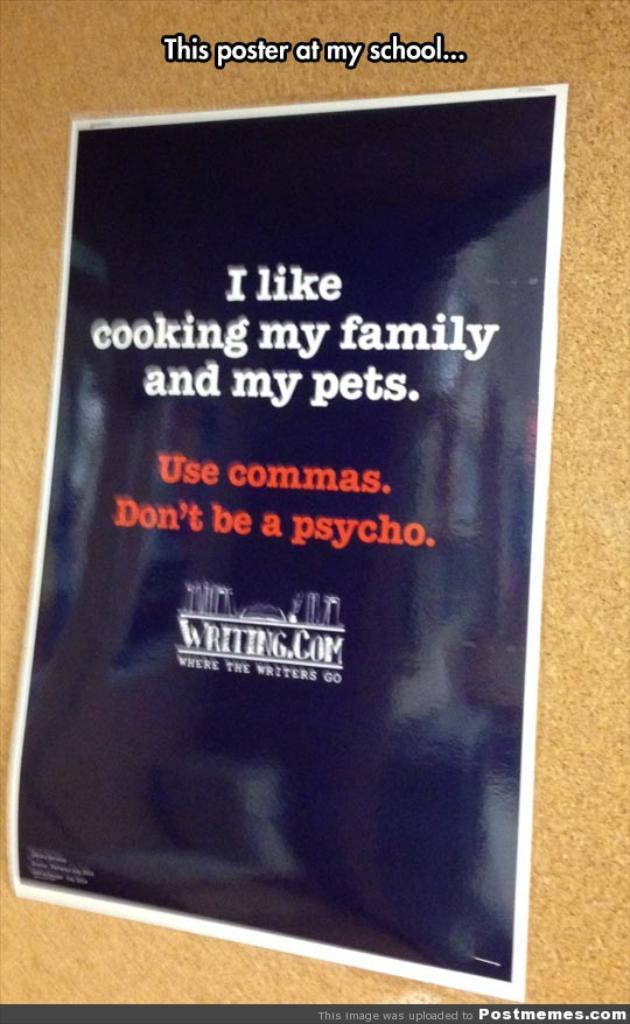<image>
Provide a brief description of the given image. A poster that says I like cooking my family and my pets. 